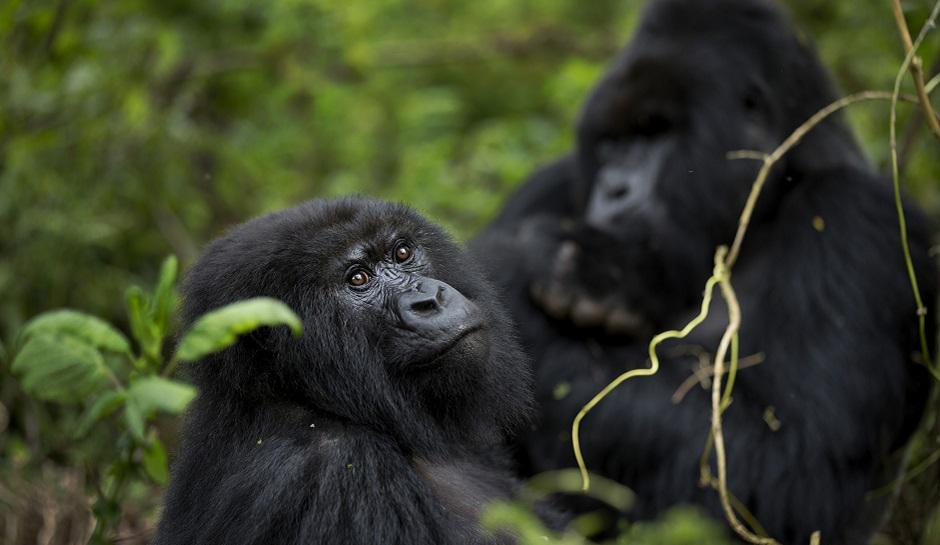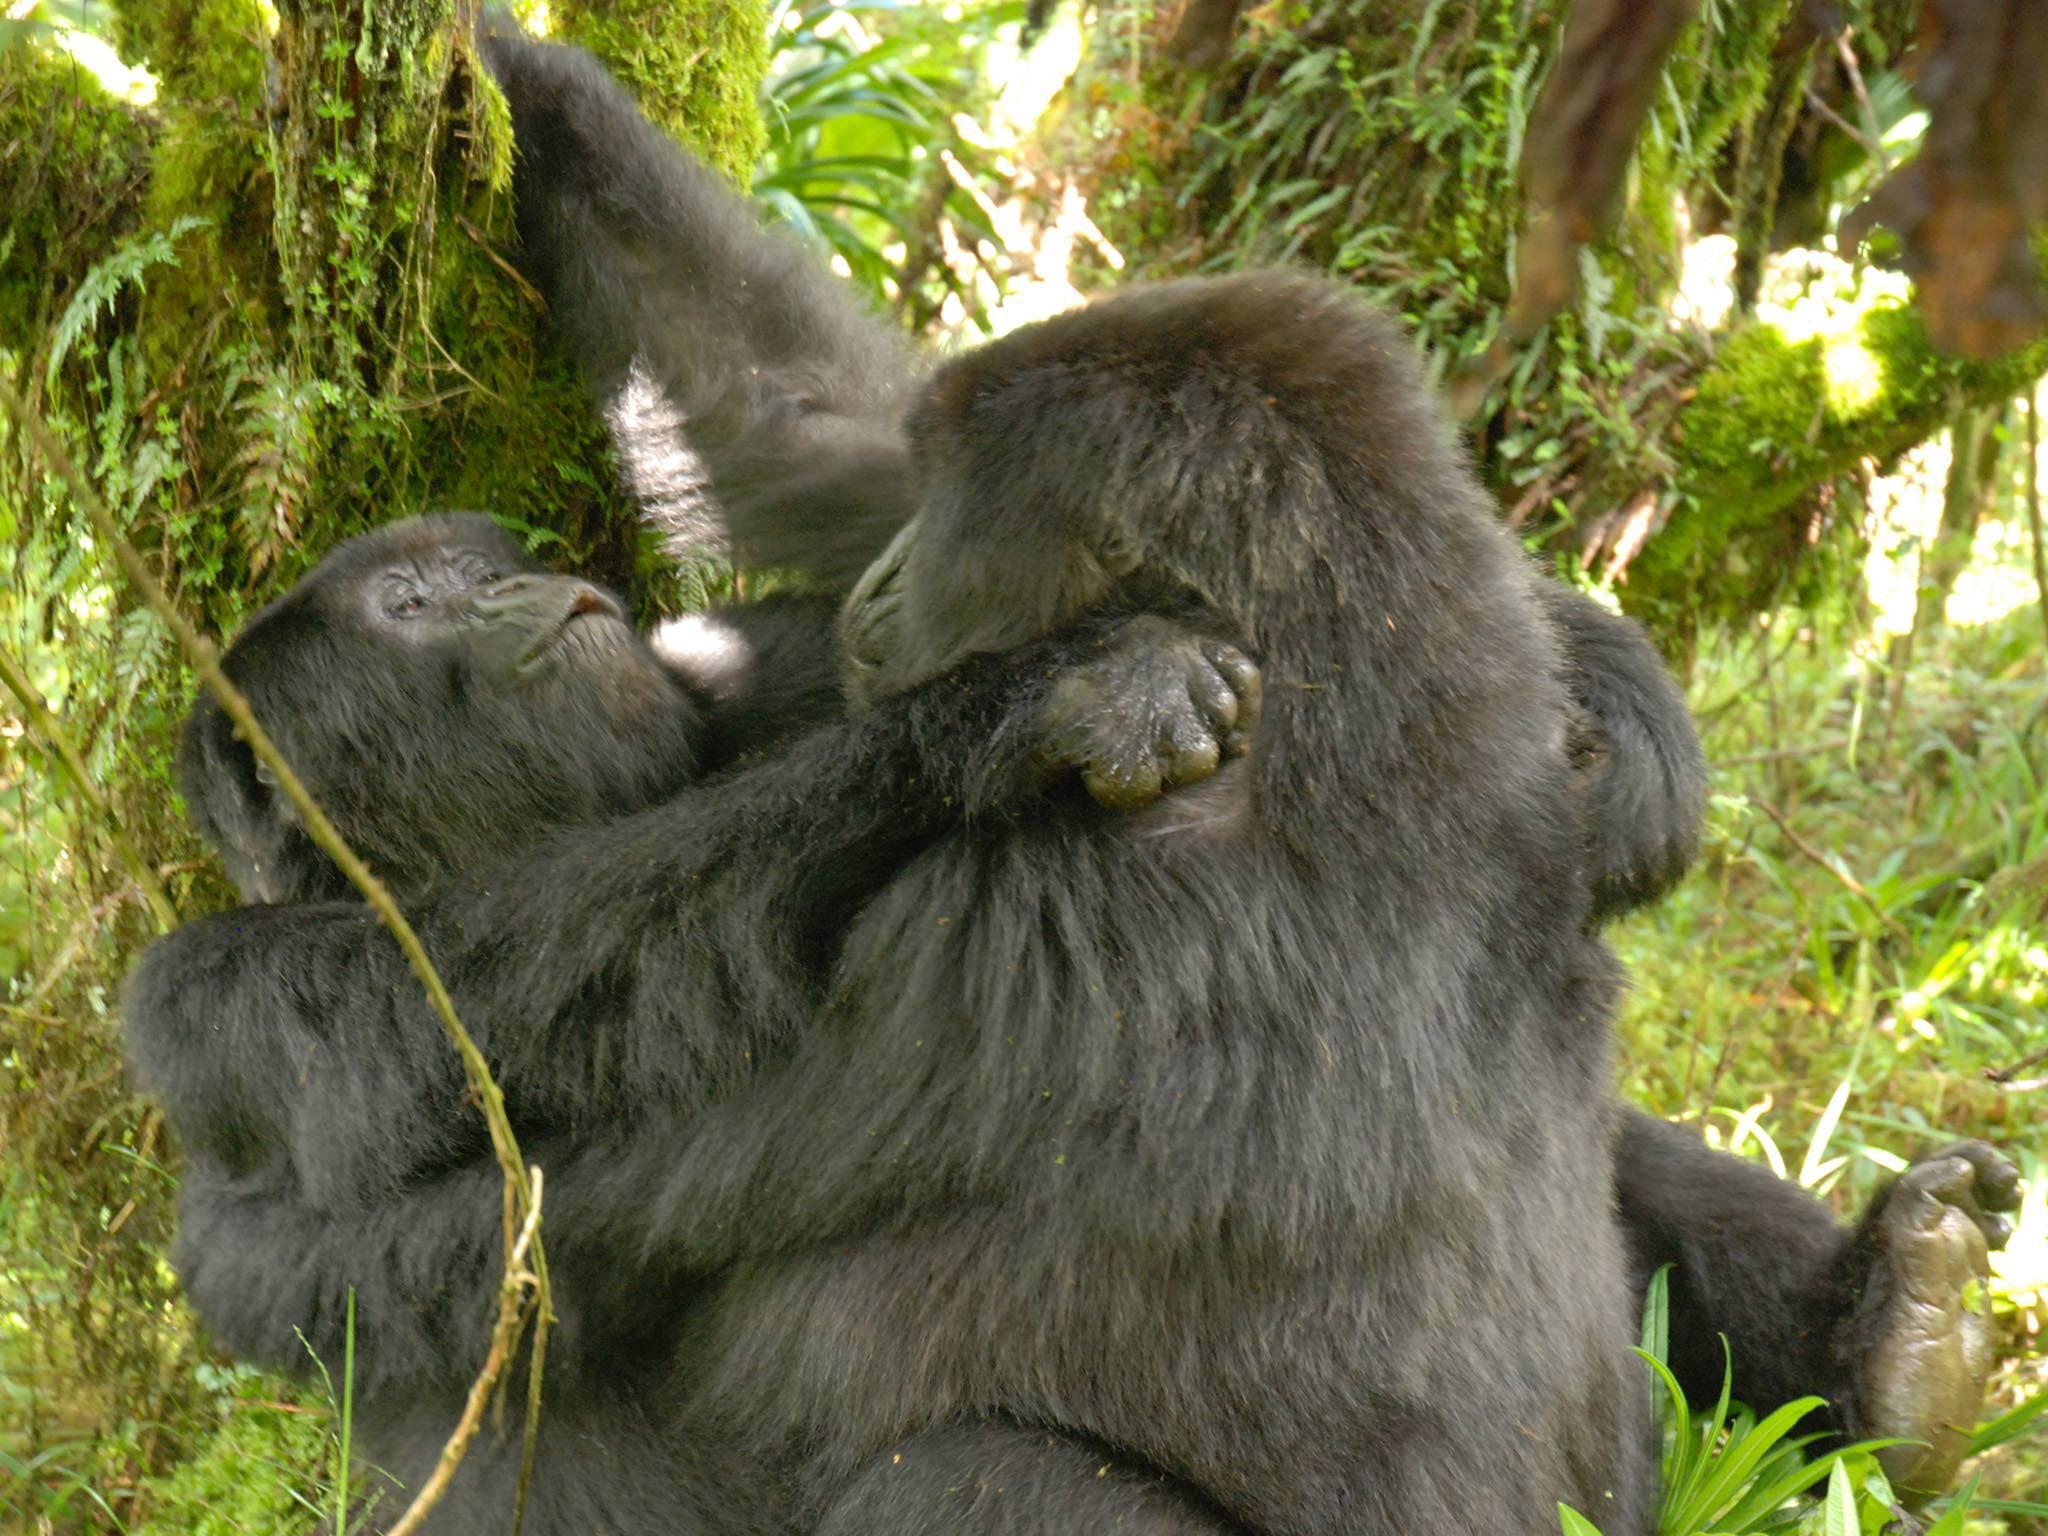The first image is the image on the left, the second image is the image on the right. Analyze the images presented: Is the assertion "At least one image shows upright gorillas engaged in a confrontation, with at least one gorilla's back turned to the camera and one gorilla with fangs bared." valid? Answer yes or no. No. 